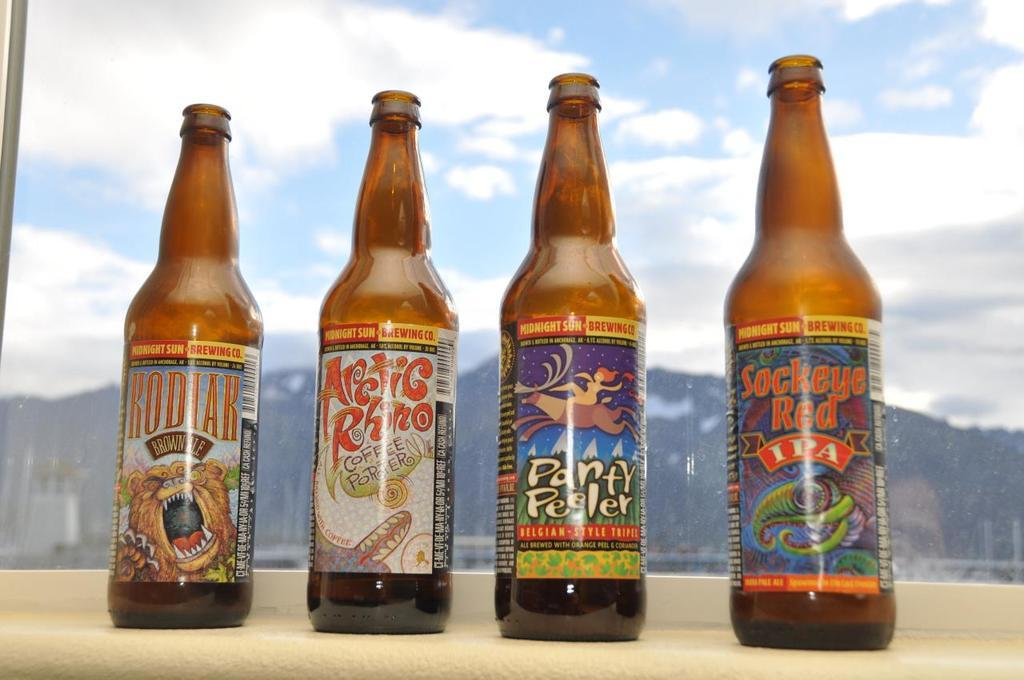<image>
Render a clear and concise summary of the photo. Four bottles of beer sit on the window sill including one called Party Peeler. 